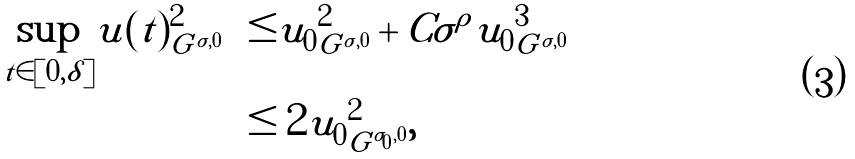Convert formula to latex. <formula><loc_0><loc_0><loc_500><loc_500>\sup _ { t \in [ 0 , \delta ] } \| u ( t ) \| ^ { 2 } _ { G ^ { \sigma , 0 } } & \leq \| u _ { 0 } \| ^ { 2 } _ { G ^ { \sigma , 0 } } + C \sigma ^ { \rho } \| u _ { 0 } \| ^ { 3 } _ { G ^ { \sigma , 0 } } \\ & \leq 2 \| u _ { 0 } \| ^ { 2 } _ { G ^ { \sigma _ { 0 } , 0 } } ,</formula> 